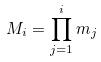Convert formula to latex. <formula><loc_0><loc_0><loc_500><loc_500>M _ { i } = \prod _ { j = 1 } ^ { i } m _ { j }</formula> 